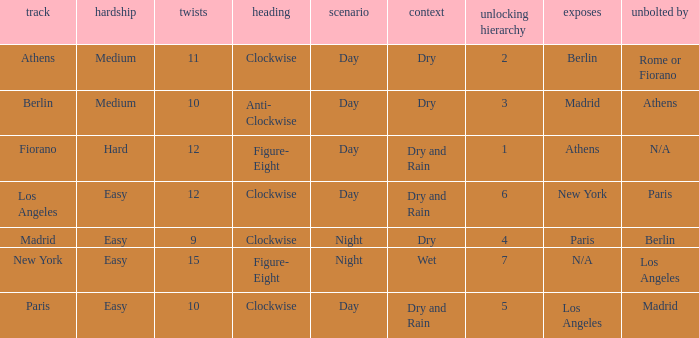What are the conditions for the athens circuit? Dry. 